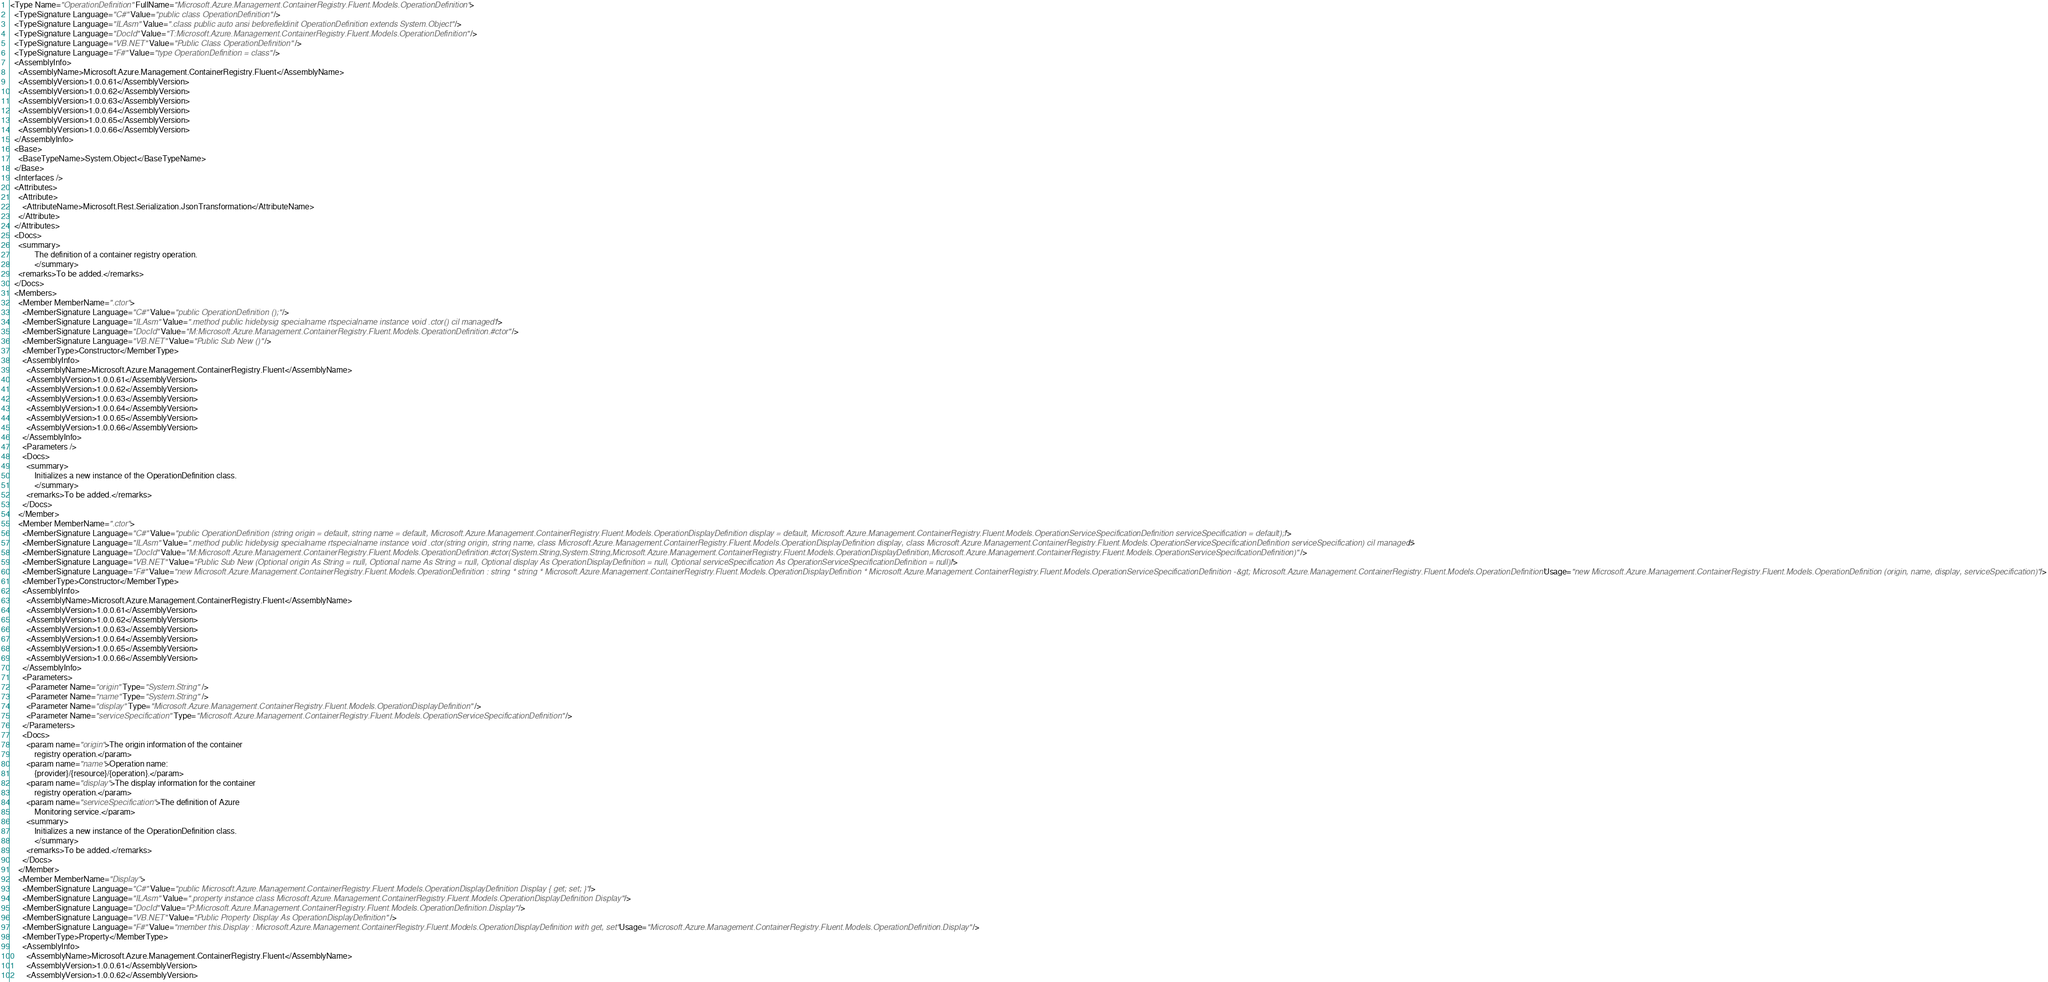<code> <loc_0><loc_0><loc_500><loc_500><_XML_><Type Name="OperationDefinition" FullName="Microsoft.Azure.Management.ContainerRegistry.Fluent.Models.OperationDefinition">
  <TypeSignature Language="C#" Value="public class OperationDefinition" />
  <TypeSignature Language="ILAsm" Value=".class public auto ansi beforefieldinit OperationDefinition extends System.Object" />
  <TypeSignature Language="DocId" Value="T:Microsoft.Azure.Management.ContainerRegistry.Fluent.Models.OperationDefinition" />
  <TypeSignature Language="VB.NET" Value="Public Class OperationDefinition" />
  <TypeSignature Language="F#" Value="type OperationDefinition = class" />
  <AssemblyInfo>
    <AssemblyName>Microsoft.Azure.Management.ContainerRegistry.Fluent</AssemblyName>
    <AssemblyVersion>1.0.0.61</AssemblyVersion>
    <AssemblyVersion>1.0.0.62</AssemblyVersion>
    <AssemblyVersion>1.0.0.63</AssemblyVersion>
    <AssemblyVersion>1.0.0.64</AssemblyVersion>
    <AssemblyVersion>1.0.0.65</AssemblyVersion>
    <AssemblyVersion>1.0.0.66</AssemblyVersion>
  </AssemblyInfo>
  <Base>
    <BaseTypeName>System.Object</BaseTypeName>
  </Base>
  <Interfaces />
  <Attributes>
    <Attribute>
      <AttributeName>Microsoft.Rest.Serialization.JsonTransformation</AttributeName>
    </Attribute>
  </Attributes>
  <Docs>
    <summary>
            The definition of a container registry operation.
            </summary>
    <remarks>To be added.</remarks>
  </Docs>
  <Members>
    <Member MemberName=".ctor">
      <MemberSignature Language="C#" Value="public OperationDefinition ();" />
      <MemberSignature Language="ILAsm" Value=".method public hidebysig specialname rtspecialname instance void .ctor() cil managed" />
      <MemberSignature Language="DocId" Value="M:Microsoft.Azure.Management.ContainerRegistry.Fluent.Models.OperationDefinition.#ctor" />
      <MemberSignature Language="VB.NET" Value="Public Sub New ()" />
      <MemberType>Constructor</MemberType>
      <AssemblyInfo>
        <AssemblyName>Microsoft.Azure.Management.ContainerRegistry.Fluent</AssemblyName>
        <AssemblyVersion>1.0.0.61</AssemblyVersion>
        <AssemblyVersion>1.0.0.62</AssemblyVersion>
        <AssemblyVersion>1.0.0.63</AssemblyVersion>
        <AssemblyVersion>1.0.0.64</AssemblyVersion>
        <AssemblyVersion>1.0.0.65</AssemblyVersion>
        <AssemblyVersion>1.0.0.66</AssemblyVersion>
      </AssemblyInfo>
      <Parameters />
      <Docs>
        <summary>
            Initializes a new instance of the OperationDefinition class.
            </summary>
        <remarks>To be added.</remarks>
      </Docs>
    </Member>
    <Member MemberName=".ctor">
      <MemberSignature Language="C#" Value="public OperationDefinition (string origin = default, string name = default, Microsoft.Azure.Management.ContainerRegistry.Fluent.Models.OperationDisplayDefinition display = default, Microsoft.Azure.Management.ContainerRegistry.Fluent.Models.OperationServiceSpecificationDefinition serviceSpecification = default);" />
      <MemberSignature Language="ILAsm" Value=".method public hidebysig specialname rtspecialname instance void .ctor(string origin, string name, class Microsoft.Azure.Management.ContainerRegistry.Fluent.Models.OperationDisplayDefinition display, class Microsoft.Azure.Management.ContainerRegistry.Fluent.Models.OperationServiceSpecificationDefinition serviceSpecification) cil managed" />
      <MemberSignature Language="DocId" Value="M:Microsoft.Azure.Management.ContainerRegistry.Fluent.Models.OperationDefinition.#ctor(System.String,System.String,Microsoft.Azure.Management.ContainerRegistry.Fluent.Models.OperationDisplayDefinition,Microsoft.Azure.Management.ContainerRegistry.Fluent.Models.OperationServiceSpecificationDefinition)" />
      <MemberSignature Language="VB.NET" Value="Public Sub New (Optional origin As String = null, Optional name As String = null, Optional display As OperationDisplayDefinition = null, Optional serviceSpecification As OperationServiceSpecificationDefinition = null)" />
      <MemberSignature Language="F#" Value="new Microsoft.Azure.Management.ContainerRegistry.Fluent.Models.OperationDefinition : string * string * Microsoft.Azure.Management.ContainerRegistry.Fluent.Models.OperationDisplayDefinition * Microsoft.Azure.Management.ContainerRegistry.Fluent.Models.OperationServiceSpecificationDefinition -&gt; Microsoft.Azure.Management.ContainerRegistry.Fluent.Models.OperationDefinition" Usage="new Microsoft.Azure.Management.ContainerRegistry.Fluent.Models.OperationDefinition (origin, name, display, serviceSpecification)" />
      <MemberType>Constructor</MemberType>
      <AssemblyInfo>
        <AssemblyName>Microsoft.Azure.Management.ContainerRegistry.Fluent</AssemblyName>
        <AssemblyVersion>1.0.0.61</AssemblyVersion>
        <AssemblyVersion>1.0.0.62</AssemblyVersion>
        <AssemblyVersion>1.0.0.63</AssemblyVersion>
        <AssemblyVersion>1.0.0.64</AssemblyVersion>
        <AssemblyVersion>1.0.0.65</AssemblyVersion>
        <AssemblyVersion>1.0.0.66</AssemblyVersion>
      </AssemblyInfo>
      <Parameters>
        <Parameter Name="origin" Type="System.String" />
        <Parameter Name="name" Type="System.String" />
        <Parameter Name="display" Type="Microsoft.Azure.Management.ContainerRegistry.Fluent.Models.OperationDisplayDefinition" />
        <Parameter Name="serviceSpecification" Type="Microsoft.Azure.Management.ContainerRegistry.Fluent.Models.OperationServiceSpecificationDefinition" />
      </Parameters>
      <Docs>
        <param name="origin">The origin information of the container
            registry operation.</param>
        <param name="name">Operation name:
            {provider}/{resource}/{operation}.</param>
        <param name="display">The display information for the container
            registry operation.</param>
        <param name="serviceSpecification">The definition of Azure
            Monitoring service.</param>
        <summary>
            Initializes a new instance of the OperationDefinition class.
            </summary>
        <remarks>To be added.</remarks>
      </Docs>
    </Member>
    <Member MemberName="Display">
      <MemberSignature Language="C#" Value="public Microsoft.Azure.Management.ContainerRegistry.Fluent.Models.OperationDisplayDefinition Display { get; set; }" />
      <MemberSignature Language="ILAsm" Value=".property instance class Microsoft.Azure.Management.ContainerRegistry.Fluent.Models.OperationDisplayDefinition Display" />
      <MemberSignature Language="DocId" Value="P:Microsoft.Azure.Management.ContainerRegistry.Fluent.Models.OperationDefinition.Display" />
      <MemberSignature Language="VB.NET" Value="Public Property Display As OperationDisplayDefinition" />
      <MemberSignature Language="F#" Value="member this.Display : Microsoft.Azure.Management.ContainerRegistry.Fluent.Models.OperationDisplayDefinition with get, set" Usage="Microsoft.Azure.Management.ContainerRegistry.Fluent.Models.OperationDefinition.Display" />
      <MemberType>Property</MemberType>
      <AssemblyInfo>
        <AssemblyName>Microsoft.Azure.Management.ContainerRegistry.Fluent</AssemblyName>
        <AssemblyVersion>1.0.0.61</AssemblyVersion>
        <AssemblyVersion>1.0.0.62</AssemblyVersion></code> 